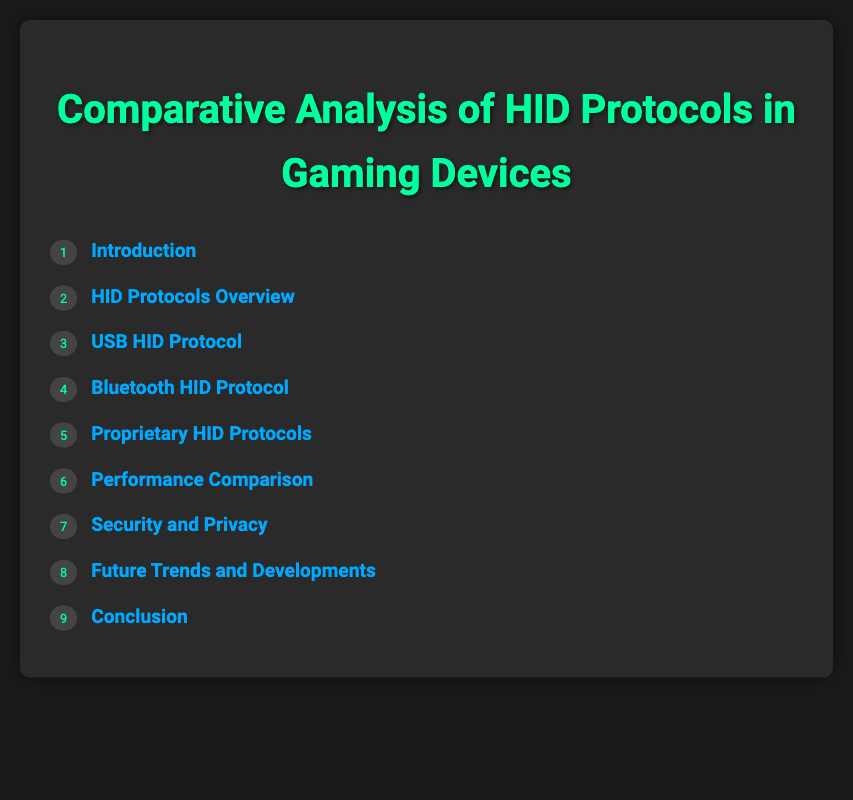What is the title of the document? The title of the document is stated at the top as "Comparative Analysis of HID Protocols in Gaming Devices."
Answer: Comparative Analysis of HID Protocols in Gaming Devices How many main sections are in the Table of Contents? The Table of Contents lists 9 main sections, each starting with a number.
Answer: 9 What does Section 6 focus on? Section 6 is titled "Performance Comparison," indicating its focus on evaluating different performance metrics.
Answer: Performance Comparison Which section discusses data encryption? Data encryption is mentioned in Section 7, specifically under "7.1 Data Encryption in HID Protocols."
Answer: Section 7 What is the focus of subsection 5.2? Subsection 5.2 discusses advantages, indicating benefits of proprietary HID protocols in gaming.
Answer: Advantages in High-Performance Gaming What is a specific topic covered under Future Trends? One of the topics is "Emerging HID Technologies in Gaming," which relates to future innovations.
Answer: Emerging HID Technologies in Gaming How many subtopics does Section 3 contain? Section 3 includes three subtopics detailing the USB HID Protocol.
Answer: 3 What area is addressed in the conclusion of the document? The conclusion section includes a summary and recommendations for developers and manufacturers.
Answer: Summary of Comparative Findings What are the two main HID protocols compared according to the overview? The main HID protocols compared are USB HID Protocol and Bluetooth HID Protocol as listed in the overview.
Answer: USB HID Protocol and Bluetooth HID Protocol 